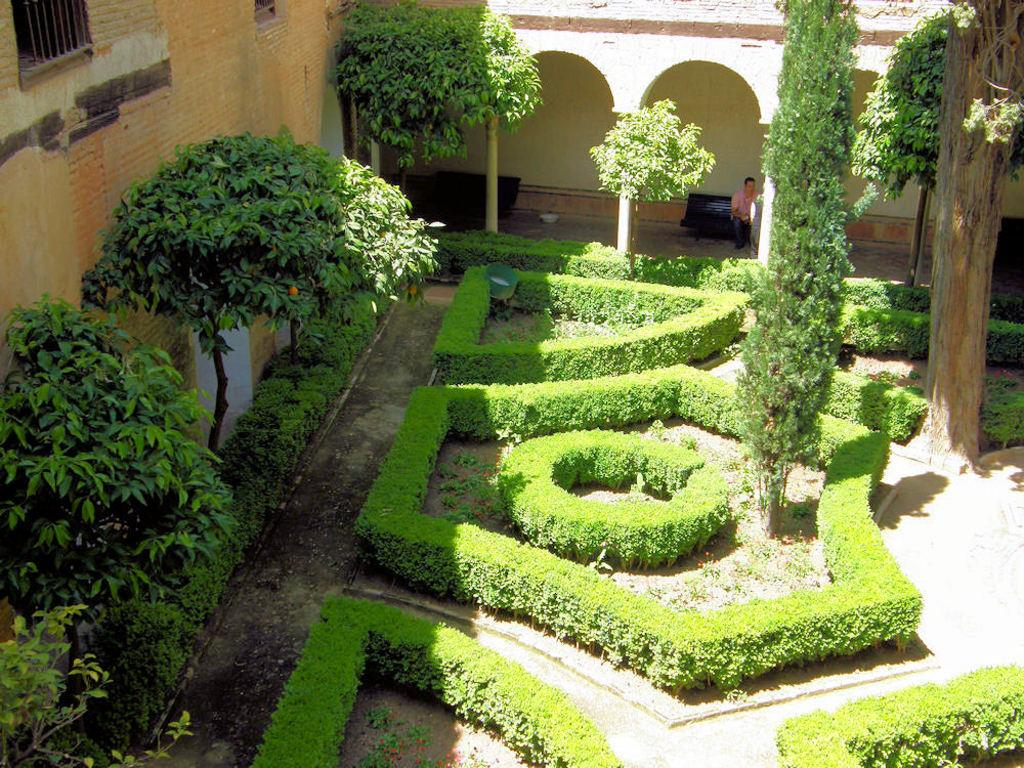What type of vegetation is present at the bottom of the image? There are plants and trees at the bottom of the image. What structure is visible behind the trees? There is a building behind the trees. Can you describe the person in the image? A man is standing in the building. What type of beam is the man using to fuel the van in the image? There is no beam or van present in the image; it features plants, trees, a building, and a man standing inside the building. 